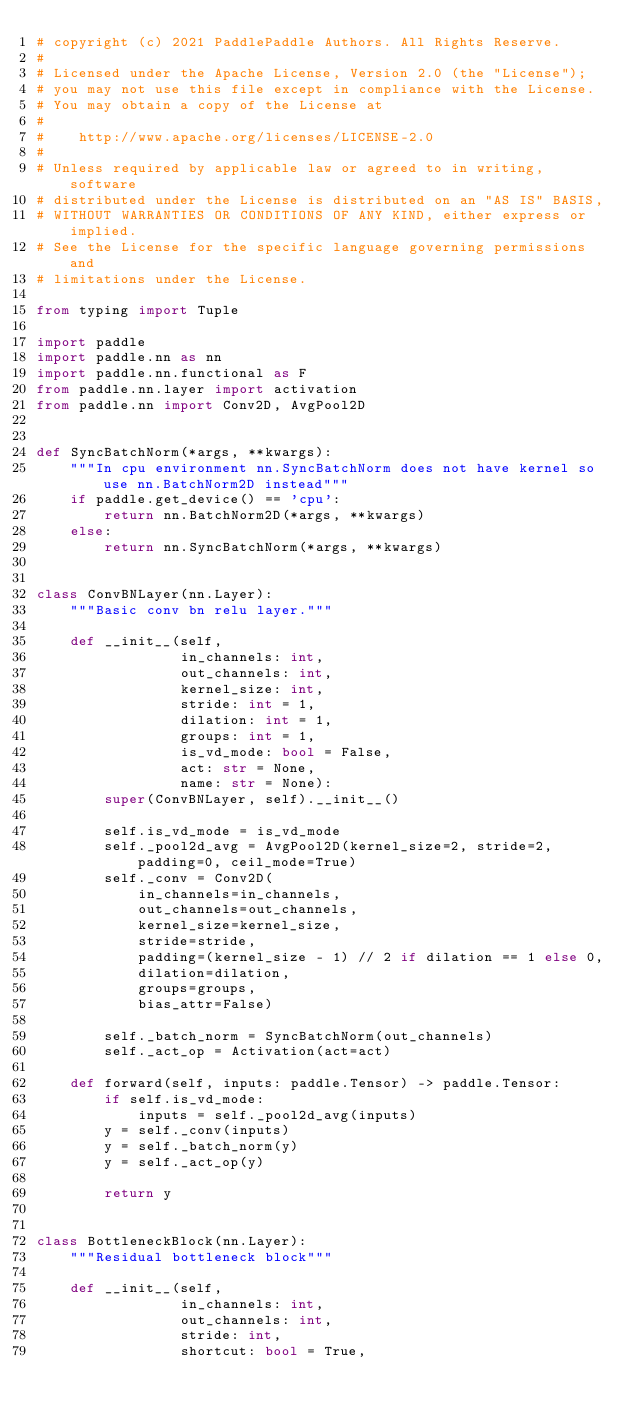Convert code to text. <code><loc_0><loc_0><loc_500><loc_500><_Python_># copyright (c) 2021 PaddlePaddle Authors. All Rights Reserve.
#
# Licensed under the Apache License, Version 2.0 (the "License");
# you may not use this file except in compliance with the License.
# You may obtain a copy of the License at
#
#    http://www.apache.org/licenses/LICENSE-2.0
#
# Unless required by applicable law or agreed to in writing, software
# distributed under the License is distributed on an "AS IS" BASIS,
# WITHOUT WARRANTIES OR CONDITIONS OF ANY KIND, either express or implied.
# See the License for the specific language governing permissions and
# limitations under the License.

from typing import Tuple

import paddle
import paddle.nn as nn
import paddle.nn.functional as F
from paddle.nn.layer import activation
from paddle.nn import Conv2D, AvgPool2D


def SyncBatchNorm(*args, **kwargs):
    """In cpu environment nn.SyncBatchNorm does not have kernel so use nn.BatchNorm2D instead"""
    if paddle.get_device() == 'cpu':
        return nn.BatchNorm2D(*args, **kwargs)
    else:
        return nn.SyncBatchNorm(*args, **kwargs)


class ConvBNLayer(nn.Layer):
    """Basic conv bn relu layer."""

    def __init__(self,
                 in_channels: int,
                 out_channels: int,
                 kernel_size: int,
                 stride: int = 1,
                 dilation: int = 1,
                 groups: int = 1,
                 is_vd_mode: bool = False,
                 act: str = None,
                 name: str = None):
        super(ConvBNLayer, self).__init__()

        self.is_vd_mode = is_vd_mode
        self._pool2d_avg = AvgPool2D(kernel_size=2, stride=2, padding=0, ceil_mode=True)
        self._conv = Conv2D(
            in_channels=in_channels,
            out_channels=out_channels,
            kernel_size=kernel_size,
            stride=stride,
            padding=(kernel_size - 1) // 2 if dilation == 1 else 0,
            dilation=dilation,
            groups=groups,
            bias_attr=False)

        self._batch_norm = SyncBatchNorm(out_channels)
        self._act_op = Activation(act=act)

    def forward(self, inputs: paddle.Tensor) -> paddle.Tensor:
        if self.is_vd_mode:
            inputs = self._pool2d_avg(inputs)
        y = self._conv(inputs)
        y = self._batch_norm(y)
        y = self._act_op(y)

        return y


class BottleneckBlock(nn.Layer):
    """Residual bottleneck block"""

    def __init__(self,
                 in_channels: int,
                 out_channels: int,
                 stride: int,
                 shortcut: bool = True,</code> 